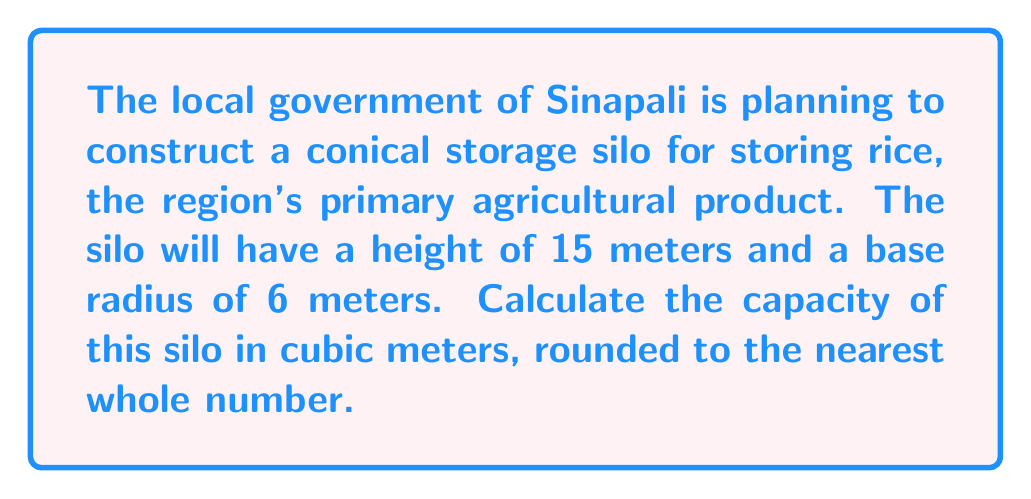What is the answer to this math problem? To solve this problem, we need to use the formula for the volume of a cone:

$$V = \frac{1}{3}\pi r^2 h$$

Where:
$V$ = volume of the cone
$r$ = radius of the base
$h$ = height of the cone

Given:
$r = 6$ meters
$h = 15$ meters

Let's substitute these values into the formula:

$$V = \frac{1}{3}\pi (6\text{ m})^2 (15\text{ m})$$

Simplify:
$$V = \frac{1}{3}\pi (36\text{ m}^2) (15\text{ m})$$
$$V = 5\pi (36\text{ m}^3)$$
$$V = 180\pi\text{ m}^3$$

Now, let's calculate this value:
$$V \approx 565.49\text{ m}^3$$

Rounding to the nearest whole number:
$$V \approx 565\text{ m}^3$$

[asy]
import geometry;

size(200);
real r = 6;
real h = 15;

pair A = (0,0), B = (r,0), C = (0,h);
draw(A--B--C--A);
draw(arc(A,r,0,180));

label("15 m", (0,h/2), W);
label("6 m", (r/2,0), S);

dot("A", A, SW);
dot("B", B, SE);
dot("C", C, N);
[/asy]

This diagram illustrates the conical silo with its dimensions.
Answer: The capacity of the conical storage silo is approximately 565 cubic meters. 